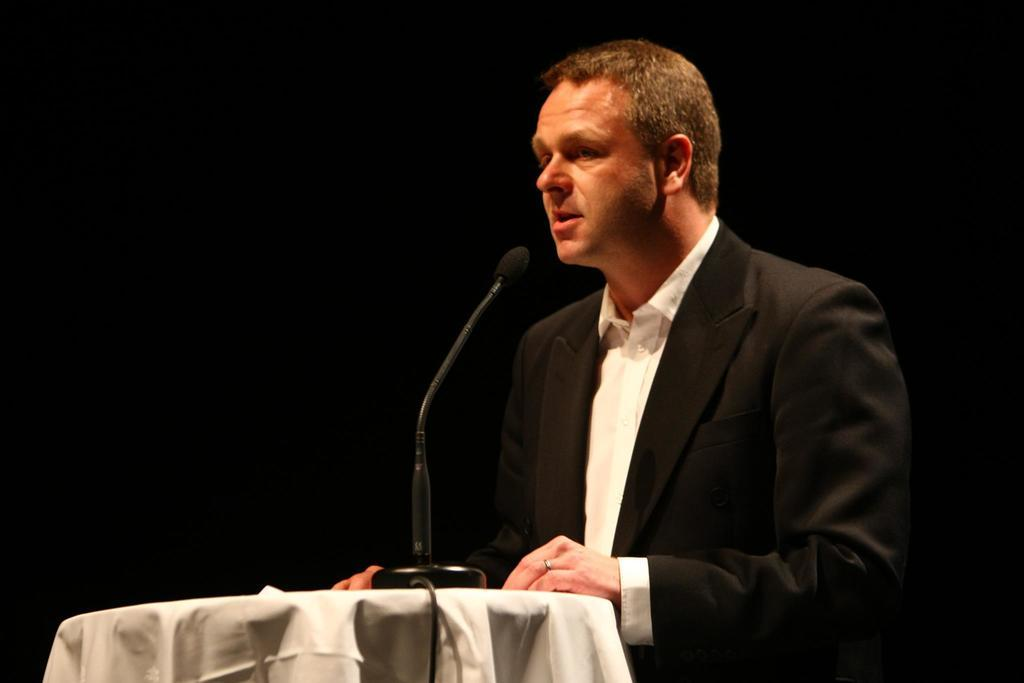What is the main object in the image? There is a table in the image. What can be seen on the table? There is a microphone (mic) and a cable on the table. Who is present in the image? There is a person in the image. What is the person doing? The person is talking. What is the color of the background in the image? The background of the image is black. Can you see a kettle boiling in the background of the image? There is no kettle present in the image, and therefore no boiling kettle can be observed. What type of knee injury does the person in the image have? There is no indication of any knee injury in the image, as the person's legs are not visible. 